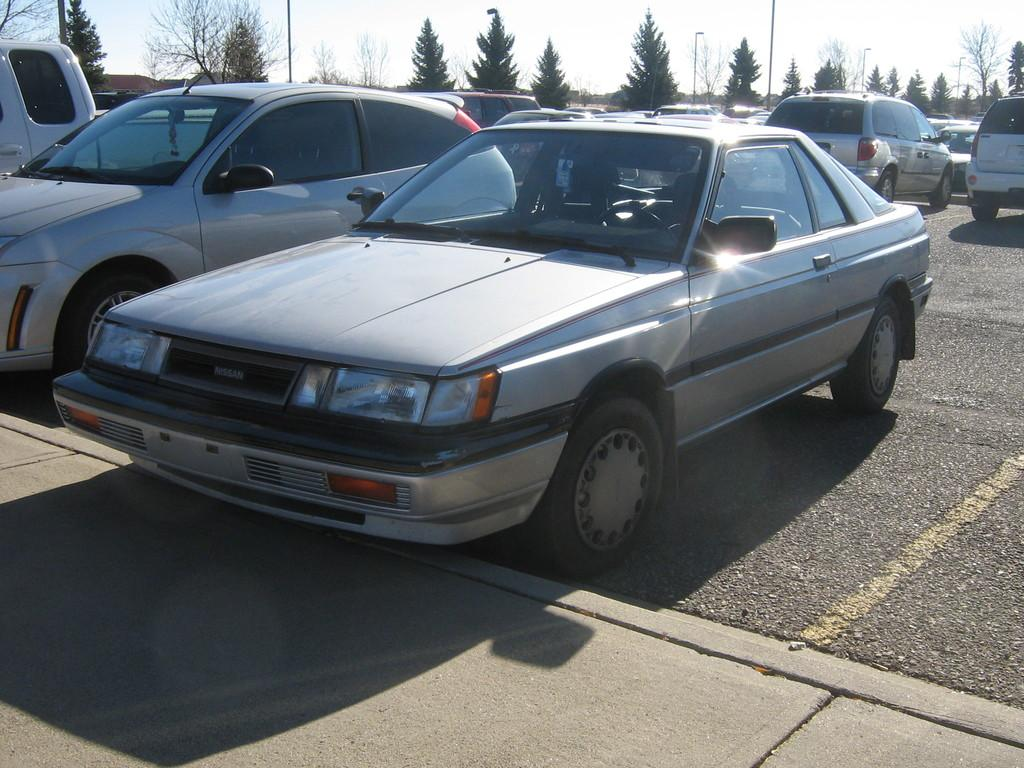What can be seen on the road in the image? There are cars parked on the road in the image. What is the purpose of the footpath visible in the image? The footpath is for pedestrians to walk on. What type of vegetation is present in the image? Trees are present in the image. What are the poles used for in the image? The poles might be used for streetlights, traffic signals, or other purposes. What is visible in the background of the image? The sky is visible in the image. What type of care is being provided to the trees in the image? There is no indication in the image that the trees are receiving any care. Is there any sleet visible in the image? There is no mention of sleet or any weather conditions in the image. 